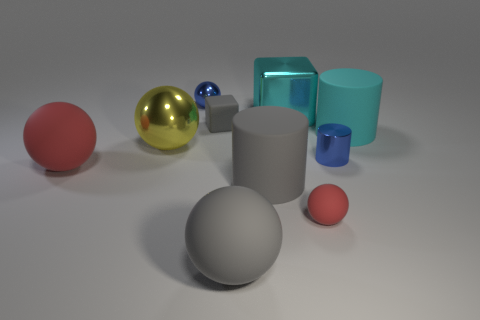How big is the blue metallic thing left of the tiny blue metallic thing in front of the small ball that is behind the small red ball?
Ensure brevity in your answer.  Small. There is a blue metallic object in front of the small shiny object on the left side of the gray rubber ball; what is its shape?
Keep it short and to the point. Cylinder. There is a large rubber thing that is to the right of the big gray cylinder; is it the same color as the big block?
Offer a very short reply. Yes. The shiny object that is both on the left side of the big gray rubber sphere and behind the big yellow metal object is what color?
Ensure brevity in your answer.  Blue. Is there a large cyan cube that has the same material as the big yellow object?
Your response must be concise. Yes. What size is the gray cylinder?
Offer a very short reply. Large. There is a red matte sphere that is right of the small metallic thing that is behind the cyan metallic thing; what size is it?
Ensure brevity in your answer.  Small. There is a gray object that is the same shape as the large yellow thing; what is it made of?
Ensure brevity in your answer.  Rubber. How many brown spheres are there?
Keep it short and to the point. 0. What color is the matte cylinder on the right side of the red thing right of the large red rubber ball that is in front of the tiny blue cylinder?
Give a very brief answer. Cyan. 